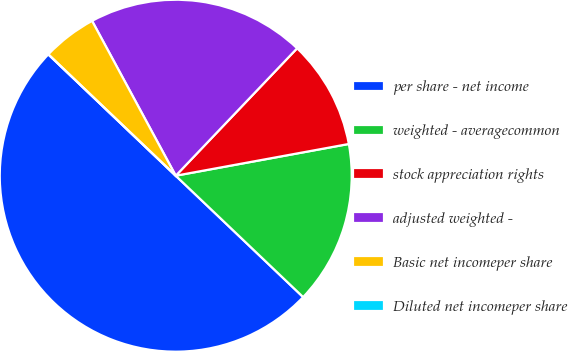Convert chart to OTSL. <chart><loc_0><loc_0><loc_500><loc_500><pie_chart><fcel>per share - net income<fcel>weighted - averagecommon<fcel>stock appreciation rights<fcel>adjusted weighted -<fcel>Basic net incomeper share<fcel>Diluted net incomeper share<nl><fcel>50.0%<fcel>15.0%<fcel>10.0%<fcel>20.0%<fcel>5.0%<fcel>0.0%<nl></chart> 